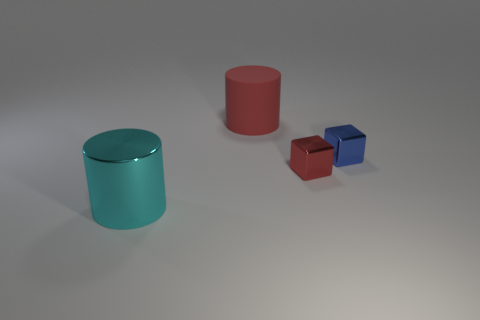What are the possible uses for these objects given their shapes and sizes? The objects, with their cylindrical and cubic shapes, could be used for educational purposes to teach geometry or for decorative purposes due to their glossy, reflective surfaces and pleasing colors. 